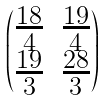<formula> <loc_0><loc_0><loc_500><loc_500>\begin{pmatrix} \frac { 1 8 } { 4 } & \frac { 1 9 } { 4 } \\ \frac { 1 9 } { 3 } & \frac { 2 8 } { 3 } \end{pmatrix}</formula> 